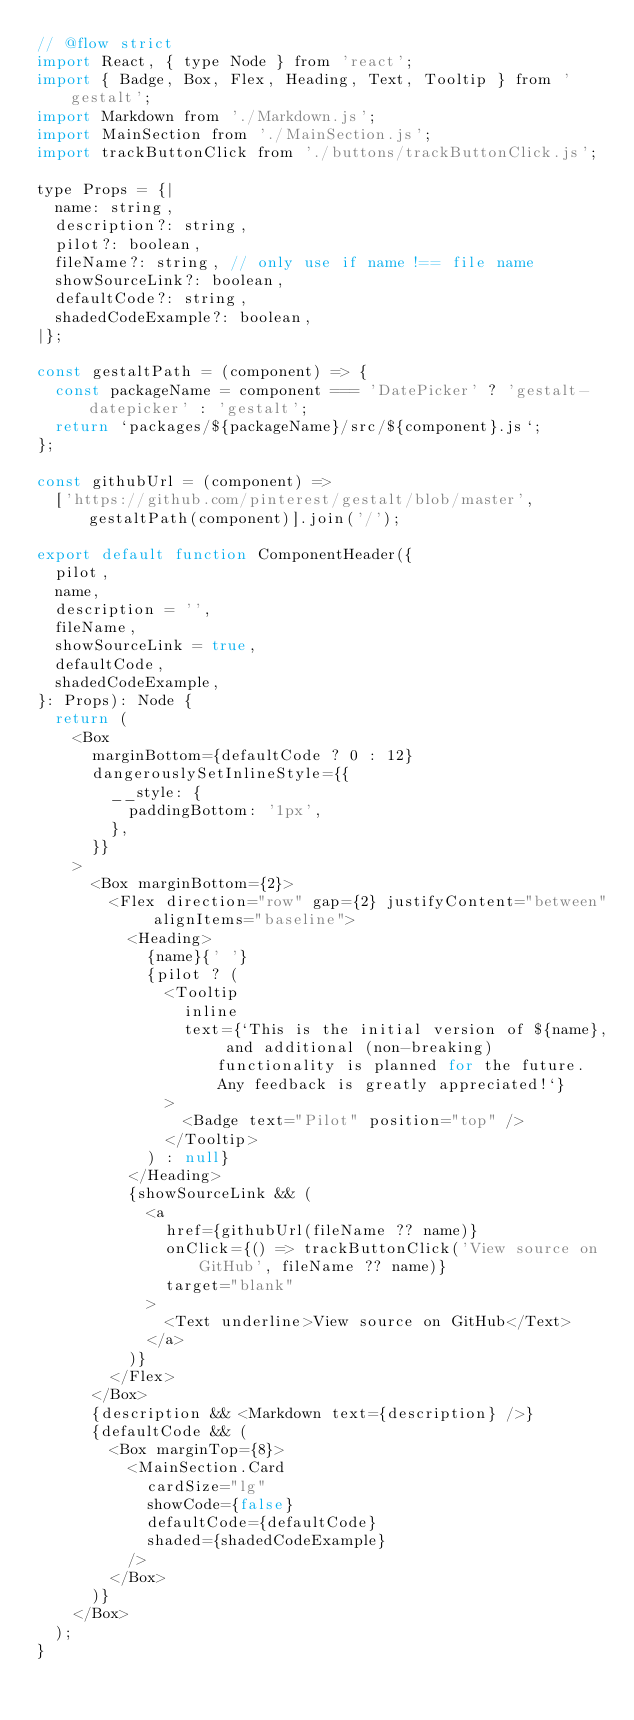Convert code to text. <code><loc_0><loc_0><loc_500><loc_500><_JavaScript_>// @flow strict
import React, { type Node } from 'react';
import { Badge, Box, Flex, Heading, Text, Tooltip } from 'gestalt';
import Markdown from './Markdown.js';
import MainSection from './MainSection.js';
import trackButtonClick from './buttons/trackButtonClick.js';

type Props = {|
  name: string,
  description?: string,
  pilot?: boolean,
  fileName?: string, // only use if name !== file name
  showSourceLink?: boolean,
  defaultCode?: string,
  shadedCodeExample?: boolean,
|};

const gestaltPath = (component) => {
  const packageName = component === 'DatePicker' ? 'gestalt-datepicker' : 'gestalt';
  return `packages/${packageName}/src/${component}.js`;
};

const githubUrl = (component) =>
  ['https://github.com/pinterest/gestalt/blob/master', gestaltPath(component)].join('/');

export default function ComponentHeader({
  pilot,
  name,
  description = '',
  fileName,
  showSourceLink = true,
  defaultCode,
  shadedCodeExample,
}: Props): Node {
  return (
    <Box
      marginBottom={defaultCode ? 0 : 12}
      dangerouslySetInlineStyle={{
        __style: {
          paddingBottom: '1px',
        },
      }}
    >
      <Box marginBottom={2}>
        <Flex direction="row" gap={2} justifyContent="between" alignItems="baseline">
          <Heading>
            {name}{' '}
            {pilot ? (
              <Tooltip
                inline
                text={`This is the initial version of ${name}, and additional (non-breaking) functionality is planned for the future. Any feedback is greatly appreciated!`}
              >
                <Badge text="Pilot" position="top" />
              </Tooltip>
            ) : null}
          </Heading>
          {showSourceLink && (
            <a
              href={githubUrl(fileName ?? name)}
              onClick={() => trackButtonClick('View source on GitHub', fileName ?? name)}
              target="blank"
            >
              <Text underline>View source on GitHub</Text>
            </a>
          )}
        </Flex>
      </Box>
      {description && <Markdown text={description} />}
      {defaultCode && (
        <Box marginTop={8}>
          <MainSection.Card
            cardSize="lg"
            showCode={false}
            defaultCode={defaultCode}
            shaded={shadedCodeExample}
          />
        </Box>
      )}
    </Box>
  );
}
</code> 